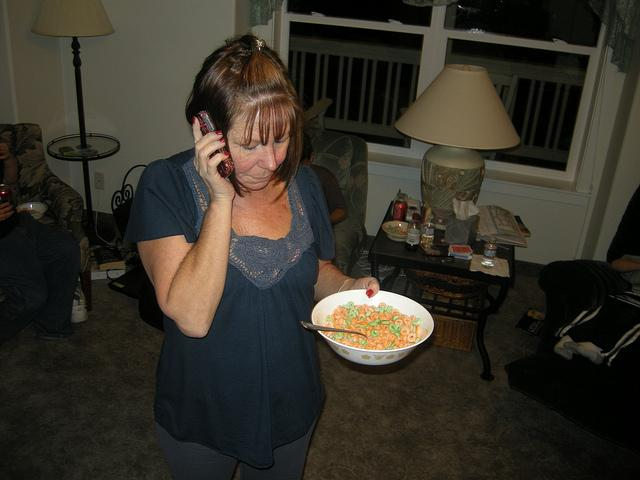What age group normally eats this food? children 